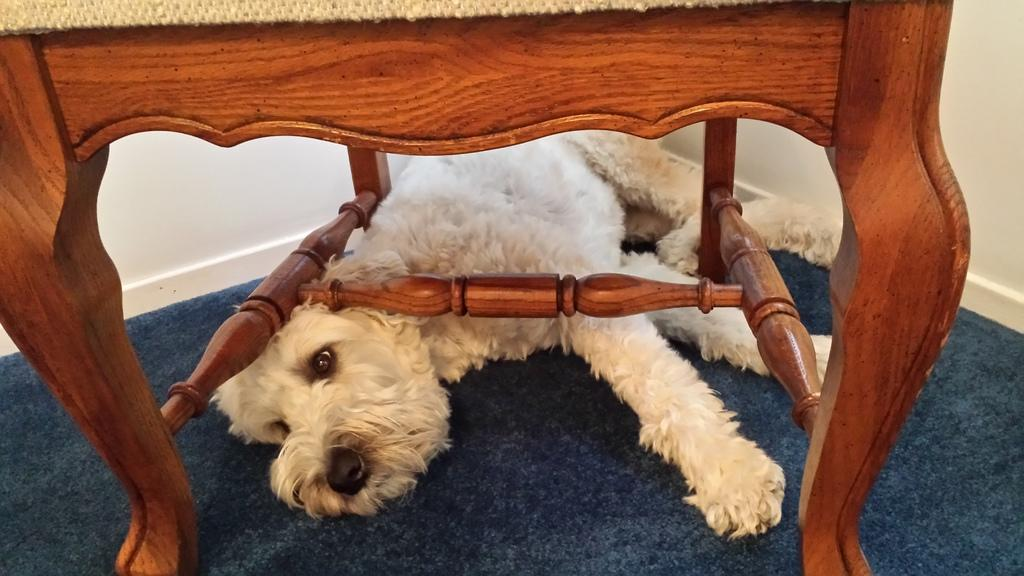What type of animal is in the image? There is a white dog in the image. What is the dog doing in the image? The dog is sleeping. What is the dog resting on in the image? The dog is on a blue mat. What is above the blue mat in the image? The blue mat is under a wooden chair. What type of car can be seen driving through the trees in the image? There is no car or trees present in the image; it features a white dog sleeping on a blue mat under a wooden chair. 